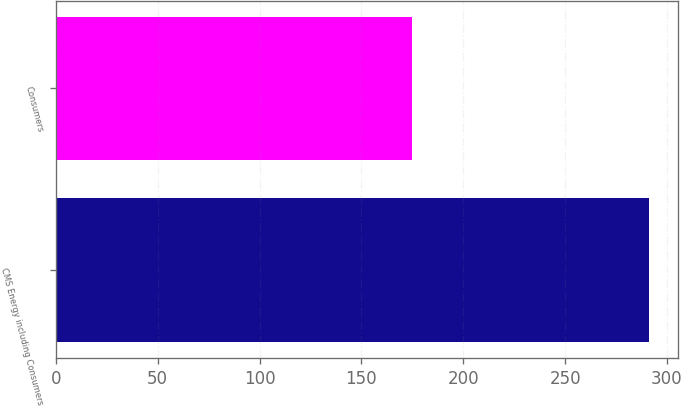<chart> <loc_0><loc_0><loc_500><loc_500><bar_chart><fcel>CMS Energy including Consumers<fcel>Consumers<nl><fcel>291<fcel>175<nl></chart> 